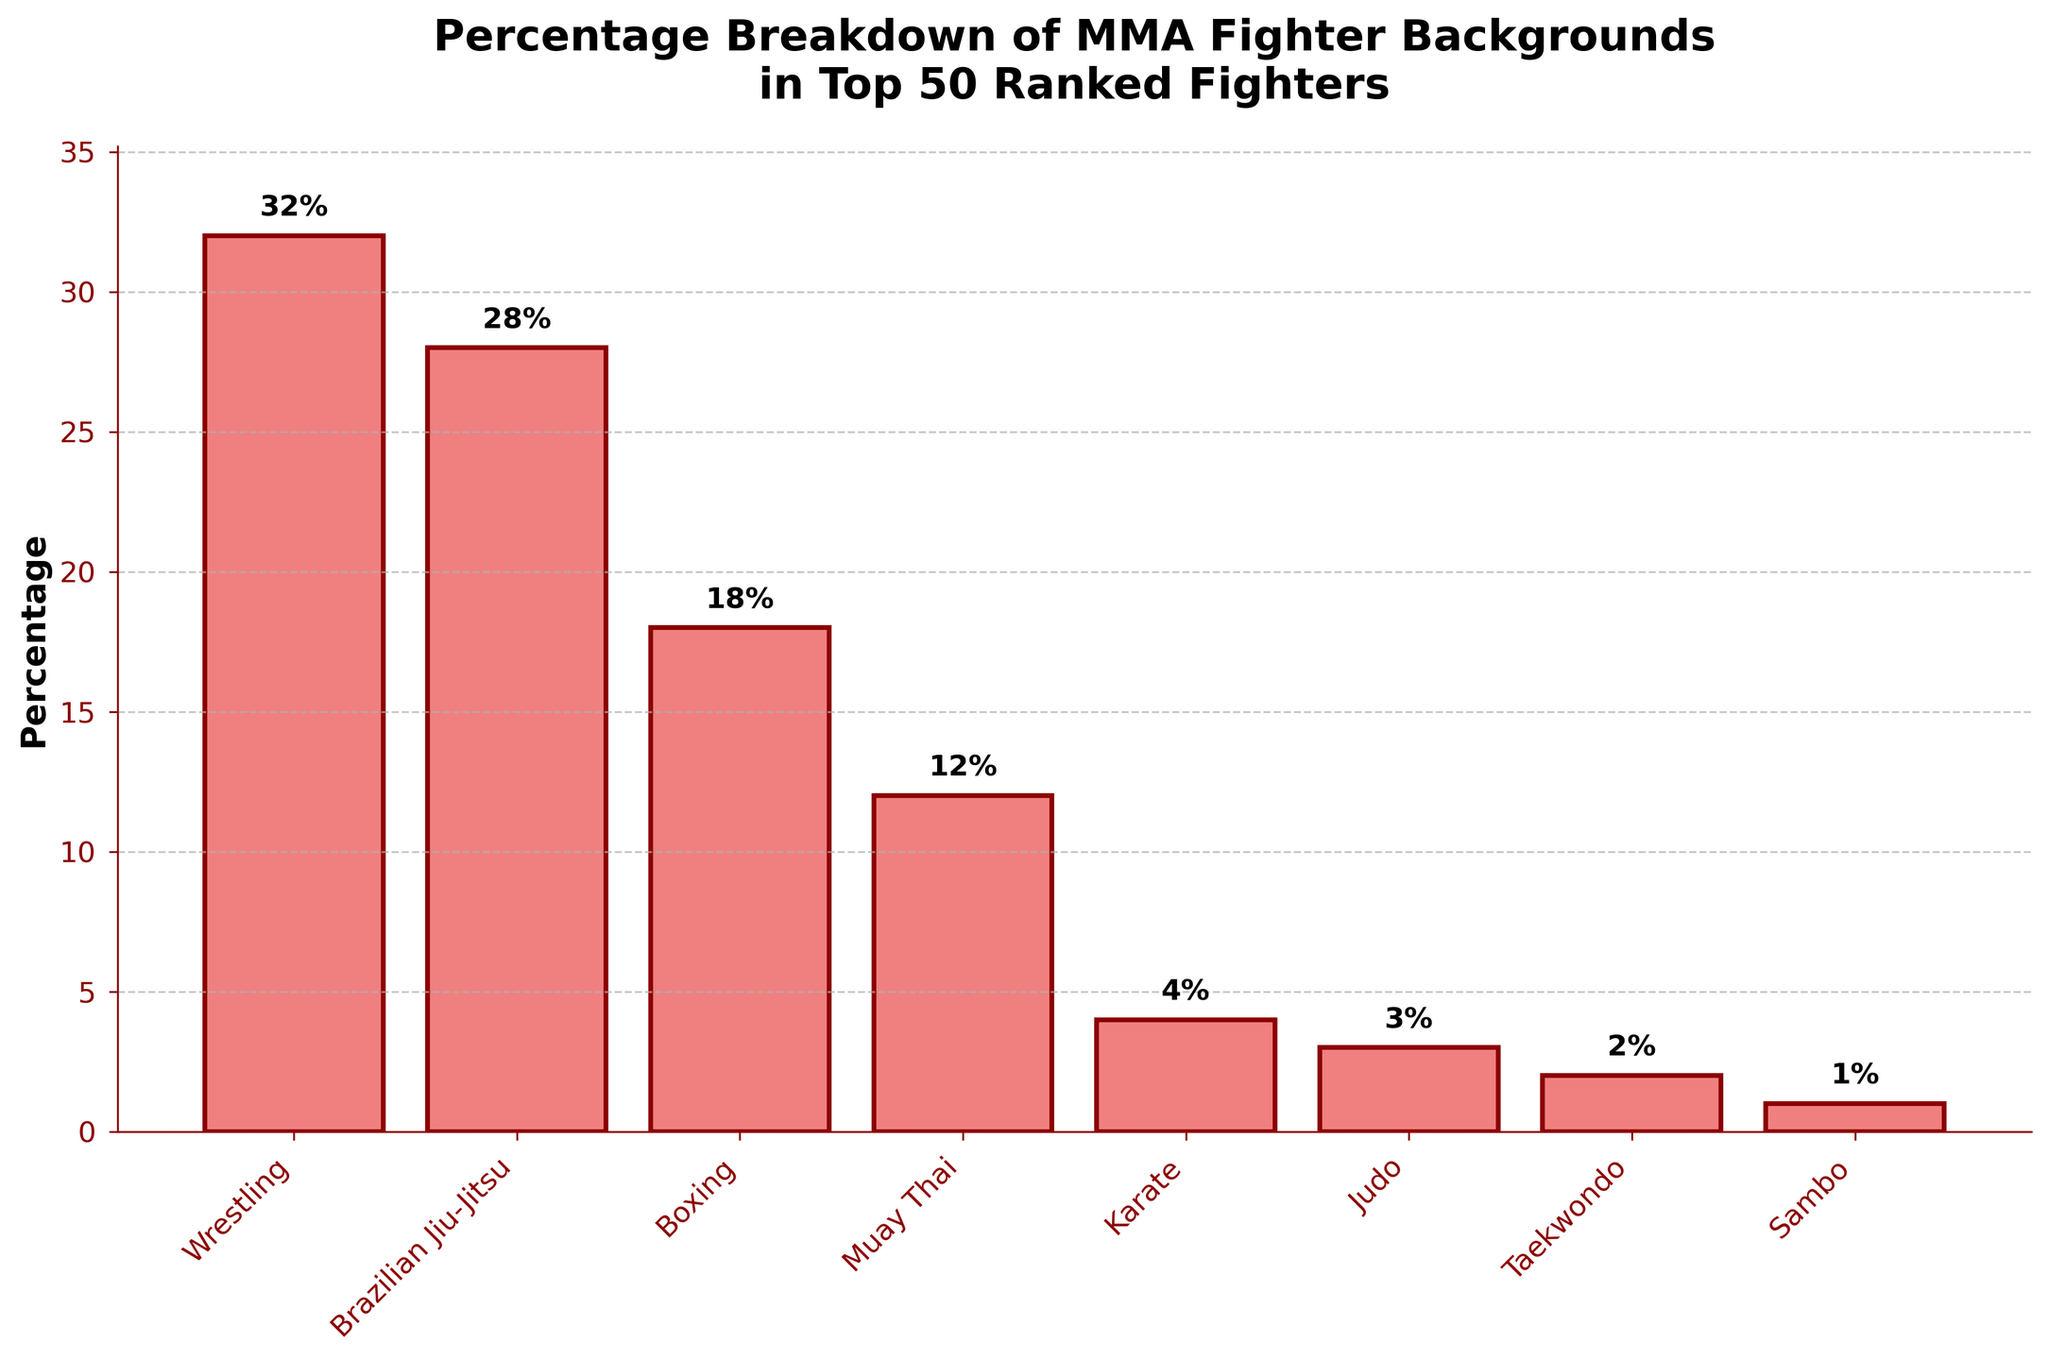What is the most common background among the top 50 ranked MMA fighters? The figure shows percentages for different backgrounds of the top 50 fighters. The highest bar represents Wrestling.
Answer: Wrestling How much more common is Wrestling compared to Muay Thai among these fighters? The bar for Wrestling shows 32%, while Muay Thai shows 12%. Subtract 12% from 32% to find the difference.
Answer: 20% Which three backgrounds have the lowest representation in the top 50 ranked fighters? The three lowest bars represent Judo, Taekwondo, and Sambo with percentages of 3%, 2%, and 1%, respectively.
Answer: Judo, Taekwondo, Sambo What is the combined percentage of fighters with Boxing and Brazilian Jiu-Jitsu backgrounds? The bar for Boxing shows 18% and for Brazilian Jiu-Jitsu shows 28%. Add these percentages: 18% + 28%.
Answer: 46% Is Boxing more common than Muay Thai for these top fighters? By comparing the heights of the bars, Boxing has a percentage of 18%, and Muay Thai has 12%. Thus, Boxing is more common.
Answer: Yes How many backgrounds have percentages greater than 20%? Only Wrestling (32%) and Brazilian Jiu-Jitsu (28%) have percentages greater than 20%.
Answer: 2 What is the total percentage of fighters with backgrounds in Brazilian Jiu-Jitsu, Muay Thai, and Karate? Sum the percentages for Brazilian Jiu-Jitsu (28%), Muay Thai (12%), and Karate (4%): 28% + 12% + 4%.
Answer: 44% By what percentage is Brazilian Jiu-Jitsu more common than Karate? Brazilian Jiu-Jitsu is 28%, and Karate is 4%. Subtract 4% from 28% to find the difference.
Answer: 24% Which background represents exactly half the percentage of Wrestling in the chart? Half of Wrestling’s percentage (32%) is 16%. None of the backgrounds listed have exactly 16%, so no background fits this criterion.
Answer: None If you combine the least represented three backgrounds, do they sum up to more than Boxing's percentage? The least represented three backgrounds are Judo (3%), Taekwondo (2%), and Sambo (1%). Adding these: 3% + 2% + 1% = 6%, which is less than Boxing's 18%.
Answer: No 